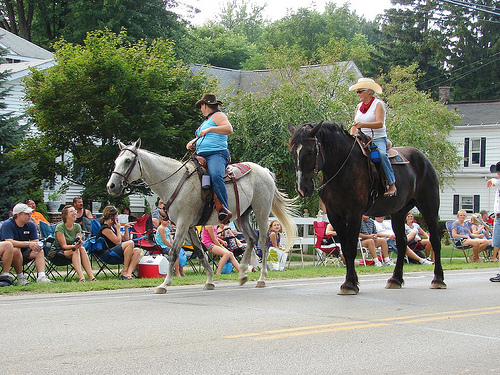<image>
Can you confirm if the woman is on the white horse? Yes. Looking at the image, I can see the woman is positioned on top of the white horse, with the white horse providing support. Where is the woman in relation to the woman? Is it to the left of the woman? No. The woman is not to the left of the woman. From this viewpoint, they have a different horizontal relationship. 